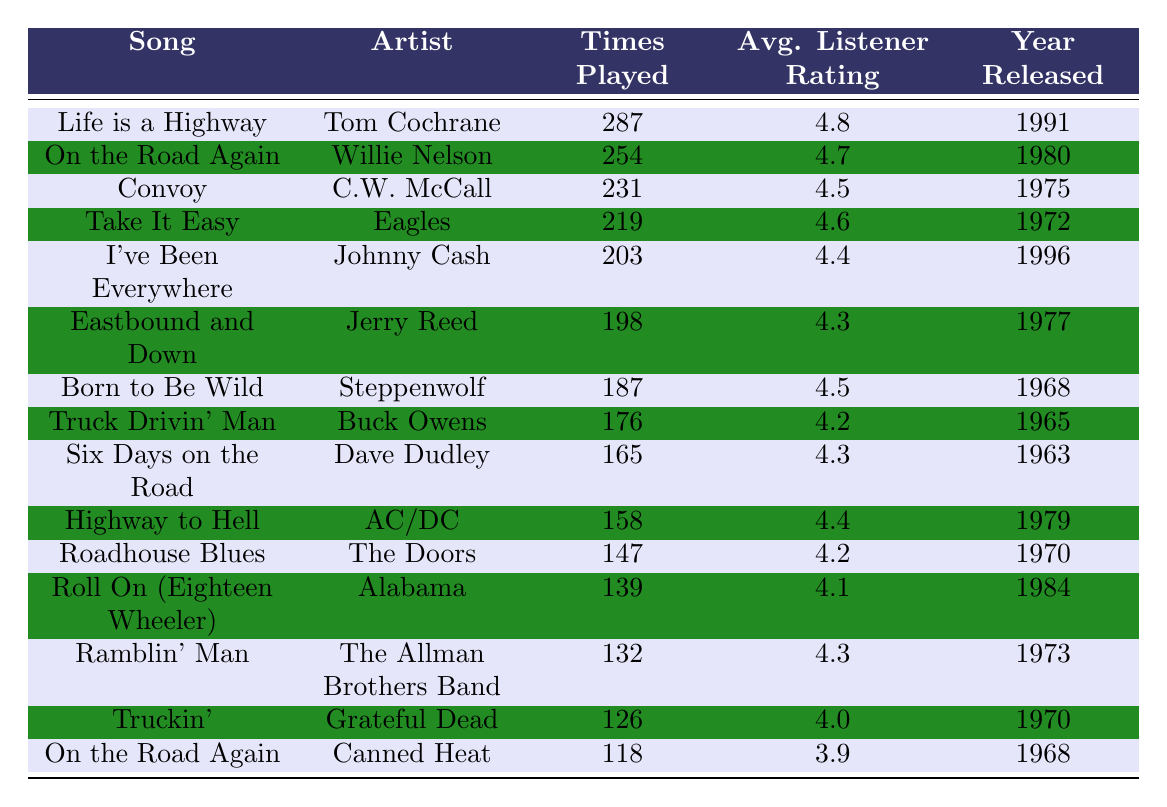What song has the highest listener rating? Looking at the column for "Average Listener Rating," the song with the highest rating is "Life is a Highway" with a rating of 4.8.
Answer: Life is a Highway Which artist performed the song with the highest number of times played? The song "Life is a Highway" by Tom Cochrane has the highest times played at 287.
Answer: Tom Cochrane How many times was "On the Road Again" by Willie Nelson played? The table shows that "On the Road Again" by Willie Nelson was played 254 times.
Answer: 254 What is the difference in times played between "Convoy" and "Roll On (Eighteen Wheeler)"? "Convoy" was played 231 times, and "Roll On (Eighteen Wheeler)" was played 139 times. The difference is 231 - 139 = 92 times.
Answer: 92 What song was released in 1970 that has a listener rating of at least 4.0? Looking for songs released in 1970 with a rating of 4.0 or higher, we find "Roadhouse Blues" with a rating of 4.2 and "Truckin'" with a rating of 4.0.
Answer: Roadhouse Blues and Truckin' Who is the artist of the song that was played the least? The song with the least times played is "On the Road Again" by Canned Heat with 118 times played.
Answer: Canned Heat Which two artists have songs that were both released in the 1970s but have ratings higher than 4.5? The songs released in the 1970s with ratings higher than 4.5 are "Convoy" by C.W. McCall (4.5) and "Highway to Hell" by AC/DC (4.4). Thus, only "Convoy" meets the criteria because the other, although in the era, has a lower rating.
Answer: C.W. McCall What is the average listener rating of songs by artists whose names start with "C"? The songs by artists starting with "C" are "Convoy" (4.5), "C.W. McCall" (same song), "Truckin'" (4.0), and "On the Road Again" (Canned Heat, 3.9). The average rating is (4.5 + 3.9 + 4.0 + 4.0) / 4 = 4.1.
Answer: 4.1 Did any song from the 1960s have a times played count above 180? Analyzing the 1960s songs, only "Born to Be Wild" (187) surpasses 180; therefore, yes, there is such a song.
Answer: Yes Which song released in 1991 has the highest listener rating? The only song released in 1991 is "Life is a Highway," which has the highest listener rating of 4.8.
Answer: Life is a Highway 